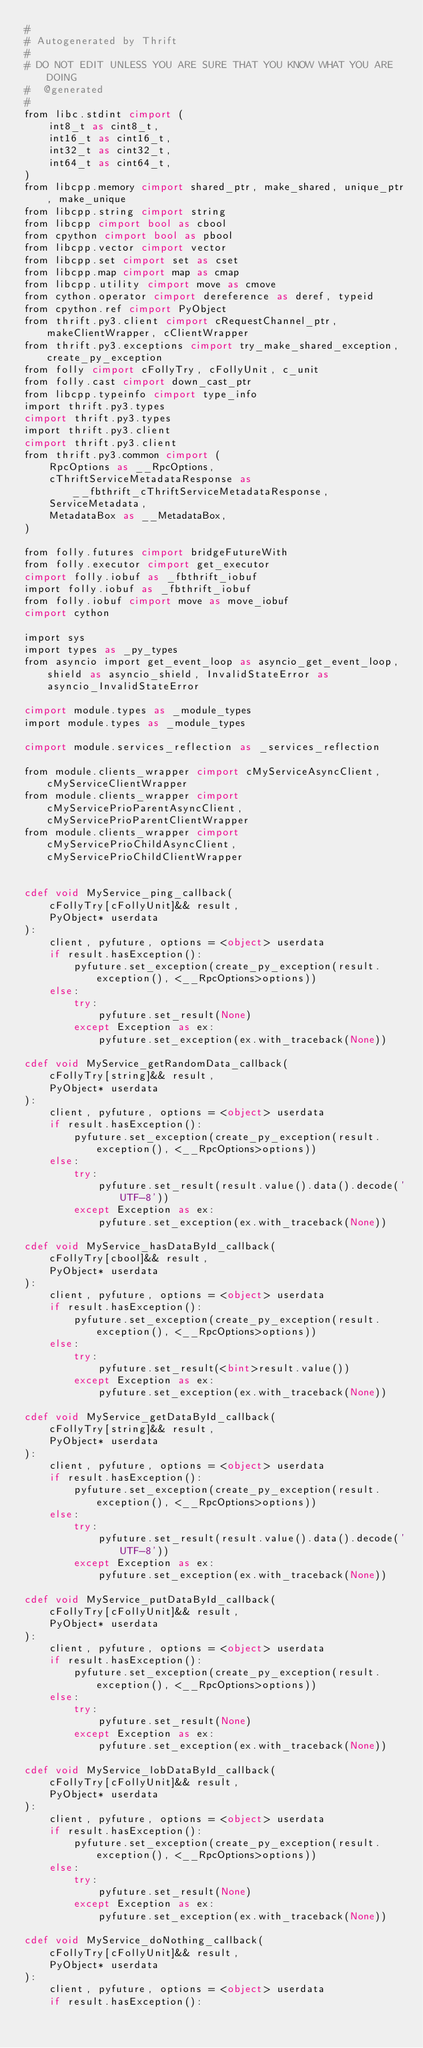<code> <loc_0><loc_0><loc_500><loc_500><_Cython_>#
# Autogenerated by Thrift
#
# DO NOT EDIT UNLESS YOU ARE SURE THAT YOU KNOW WHAT YOU ARE DOING
#  @generated
#
from libc.stdint cimport (
    int8_t as cint8_t,
    int16_t as cint16_t,
    int32_t as cint32_t,
    int64_t as cint64_t,
)
from libcpp.memory cimport shared_ptr, make_shared, unique_ptr, make_unique
from libcpp.string cimport string
from libcpp cimport bool as cbool
from cpython cimport bool as pbool
from libcpp.vector cimport vector
from libcpp.set cimport set as cset
from libcpp.map cimport map as cmap
from libcpp.utility cimport move as cmove
from cython.operator cimport dereference as deref, typeid
from cpython.ref cimport PyObject
from thrift.py3.client cimport cRequestChannel_ptr, makeClientWrapper, cClientWrapper
from thrift.py3.exceptions cimport try_make_shared_exception, create_py_exception
from folly cimport cFollyTry, cFollyUnit, c_unit
from folly.cast cimport down_cast_ptr
from libcpp.typeinfo cimport type_info
import thrift.py3.types
cimport thrift.py3.types
import thrift.py3.client
cimport thrift.py3.client
from thrift.py3.common cimport (
    RpcOptions as __RpcOptions,
    cThriftServiceMetadataResponse as __fbthrift_cThriftServiceMetadataResponse,
    ServiceMetadata,
    MetadataBox as __MetadataBox,
)

from folly.futures cimport bridgeFutureWith
from folly.executor cimport get_executor
cimport folly.iobuf as _fbthrift_iobuf
import folly.iobuf as _fbthrift_iobuf
from folly.iobuf cimport move as move_iobuf
cimport cython

import sys
import types as _py_types
from asyncio import get_event_loop as asyncio_get_event_loop, shield as asyncio_shield, InvalidStateError as asyncio_InvalidStateError

cimport module.types as _module_types
import module.types as _module_types

cimport module.services_reflection as _services_reflection

from module.clients_wrapper cimport cMyServiceAsyncClient, cMyServiceClientWrapper
from module.clients_wrapper cimport cMyServicePrioParentAsyncClient, cMyServicePrioParentClientWrapper
from module.clients_wrapper cimport cMyServicePrioChildAsyncClient, cMyServicePrioChildClientWrapper


cdef void MyService_ping_callback(
    cFollyTry[cFollyUnit]&& result,
    PyObject* userdata
):
    client, pyfuture, options = <object> userdata  
    if result.hasException():
        pyfuture.set_exception(create_py_exception(result.exception(), <__RpcOptions>options))
    else:
        try:
            pyfuture.set_result(None)
        except Exception as ex:
            pyfuture.set_exception(ex.with_traceback(None))

cdef void MyService_getRandomData_callback(
    cFollyTry[string]&& result,
    PyObject* userdata
):
    client, pyfuture, options = <object> userdata  
    if result.hasException():
        pyfuture.set_exception(create_py_exception(result.exception(), <__RpcOptions>options))
    else:
        try:
            pyfuture.set_result(result.value().data().decode('UTF-8'))
        except Exception as ex:
            pyfuture.set_exception(ex.with_traceback(None))

cdef void MyService_hasDataById_callback(
    cFollyTry[cbool]&& result,
    PyObject* userdata
):
    client, pyfuture, options = <object> userdata  
    if result.hasException():
        pyfuture.set_exception(create_py_exception(result.exception(), <__RpcOptions>options))
    else:
        try:
            pyfuture.set_result(<bint>result.value())
        except Exception as ex:
            pyfuture.set_exception(ex.with_traceback(None))

cdef void MyService_getDataById_callback(
    cFollyTry[string]&& result,
    PyObject* userdata
):
    client, pyfuture, options = <object> userdata  
    if result.hasException():
        pyfuture.set_exception(create_py_exception(result.exception(), <__RpcOptions>options))
    else:
        try:
            pyfuture.set_result(result.value().data().decode('UTF-8'))
        except Exception as ex:
            pyfuture.set_exception(ex.with_traceback(None))

cdef void MyService_putDataById_callback(
    cFollyTry[cFollyUnit]&& result,
    PyObject* userdata
):
    client, pyfuture, options = <object> userdata  
    if result.hasException():
        pyfuture.set_exception(create_py_exception(result.exception(), <__RpcOptions>options))
    else:
        try:
            pyfuture.set_result(None)
        except Exception as ex:
            pyfuture.set_exception(ex.with_traceback(None))

cdef void MyService_lobDataById_callback(
    cFollyTry[cFollyUnit]&& result,
    PyObject* userdata
):
    client, pyfuture, options = <object> userdata  
    if result.hasException():
        pyfuture.set_exception(create_py_exception(result.exception(), <__RpcOptions>options))
    else:
        try:
            pyfuture.set_result(None)
        except Exception as ex:
            pyfuture.set_exception(ex.with_traceback(None))

cdef void MyService_doNothing_callback(
    cFollyTry[cFollyUnit]&& result,
    PyObject* userdata
):
    client, pyfuture, options = <object> userdata  
    if result.hasException():</code> 